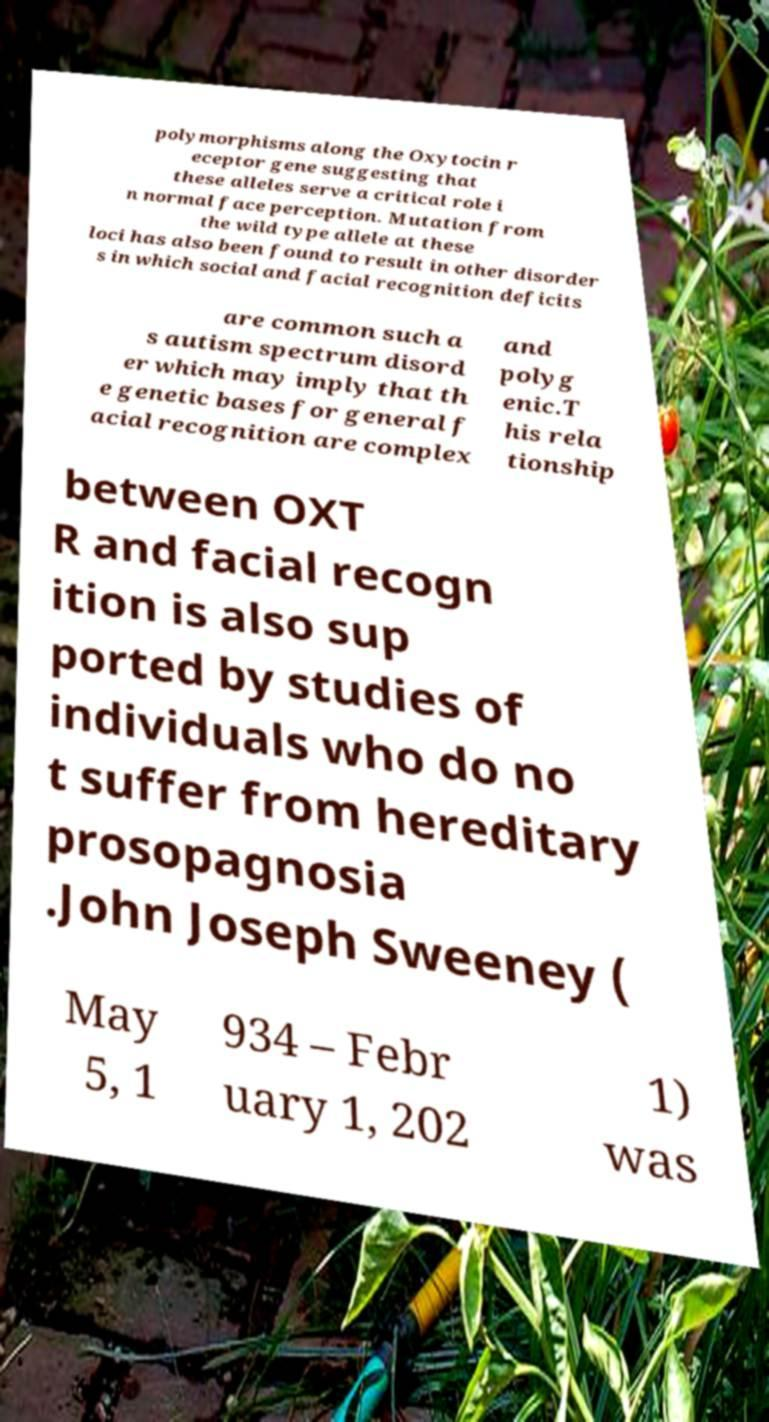Could you extract and type out the text from this image? polymorphisms along the Oxytocin r eceptor gene suggesting that these alleles serve a critical role i n normal face perception. Mutation from the wild type allele at these loci has also been found to result in other disorder s in which social and facial recognition deficits are common such a s autism spectrum disord er which may imply that th e genetic bases for general f acial recognition are complex and polyg enic.T his rela tionship between OXT R and facial recogn ition is also sup ported by studies of individuals who do no t suffer from hereditary prosopagnosia .John Joseph Sweeney ( May 5, 1 934 – Febr uary 1, 202 1) was 